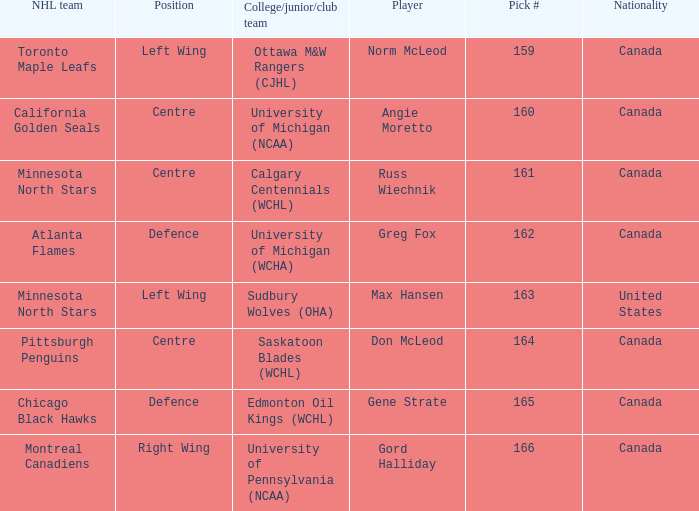What team did Russ Wiechnik, on the centre position, come from? Calgary Centennials (WCHL). 